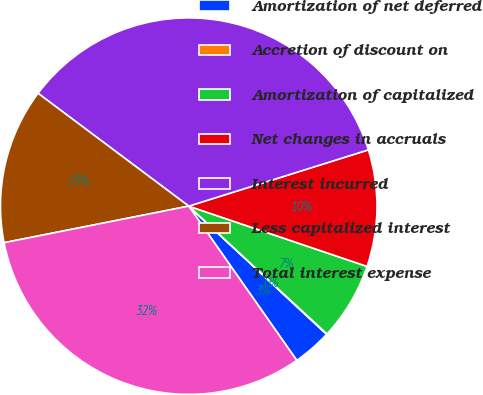<chart> <loc_0><loc_0><loc_500><loc_500><pie_chart><fcel>Amortization of net deferred<fcel>Accretion of discount on<fcel>Amortization of capitalized<fcel>Net changes in accruals<fcel>Interest incurred<fcel>Less capitalized interest<fcel>Total interest expense<nl><fcel>3.36%<fcel>0.04%<fcel>6.69%<fcel>10.02%<fcel>34.94%<fcel>13.34%<fcel>31.61%<nl></chart> 